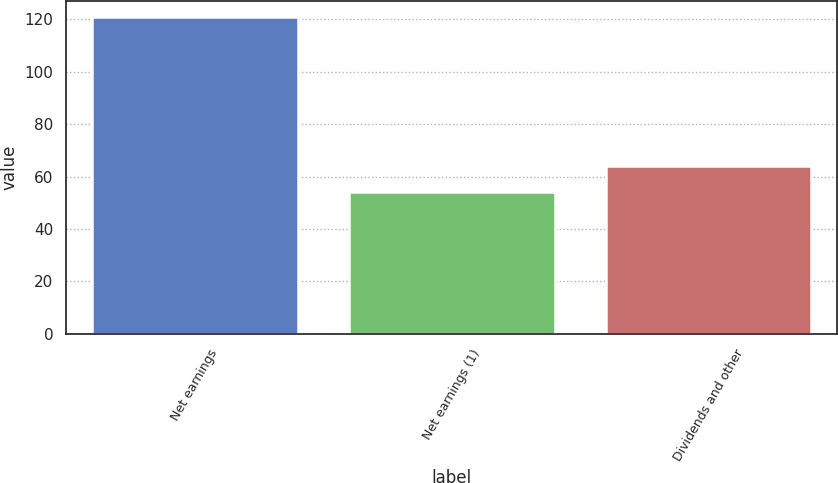Convert chart. <chart><loc_0><loc_0><loc_500><loc_500><bar_chart><fcel>Net earnings<fcel>Net earnings (1)<fcel>Dividends and other<nl><fcel>121<fcel>54<fcel>64<nl></chart> 